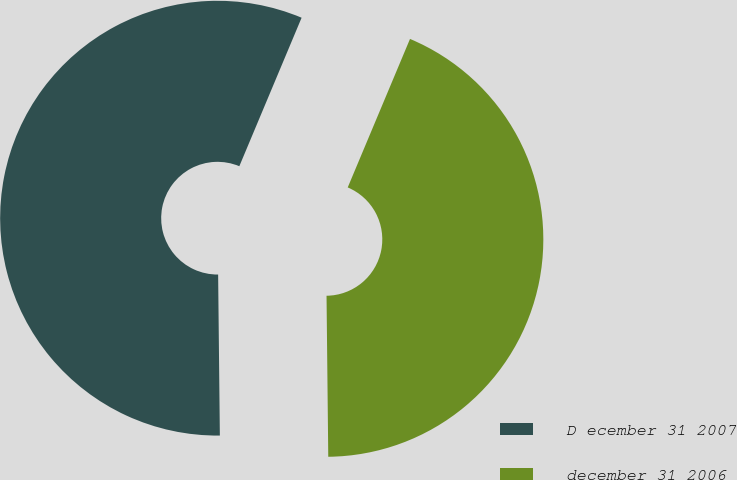Convert chart. <chart><loc_0><loc_0><loc_500><loc_500><pie_chart><fcel>D ecember 31 2007<fcel>december 31 2006<nl><fcel>56.49%<fcel>43.51%<nl></chart> 